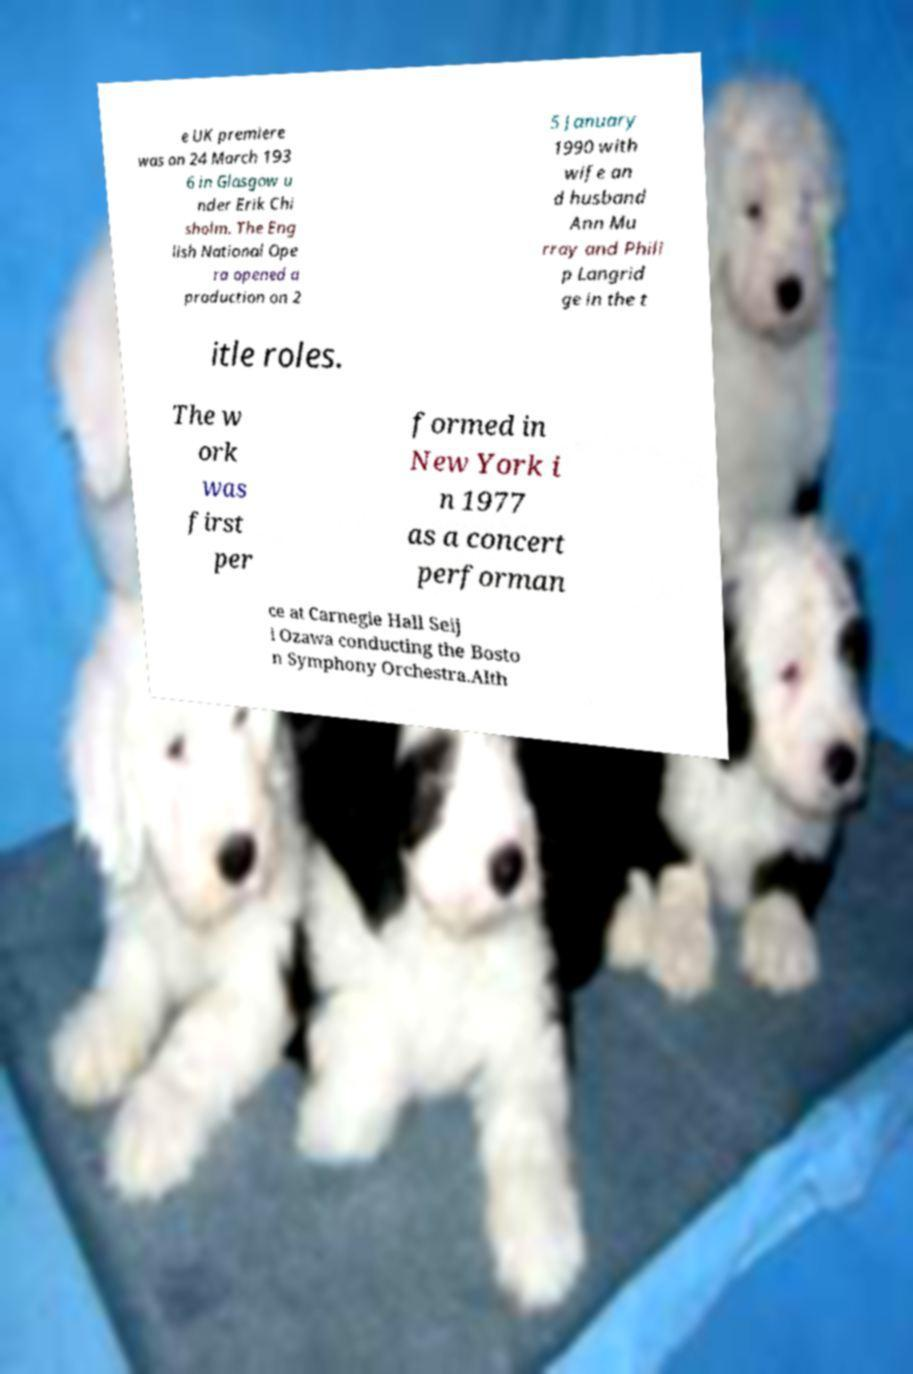Please identify and transcribe the text found in this image. e UK premiere was on 24 March 193 6 in Glasgow u nder Erik Chi sholm. The Eng lish National Ope ra opened a production on 2 5 January 1990 with wife an d husband Ann Mu rray and Phili p Langrid ge in the t itle roles. The w ork was first per formed in New York i n 1977 as a concert performan ce at Carnegie Hall Seij i Ozawa conducting the Bosto n Symphony Orchestra.Alth 